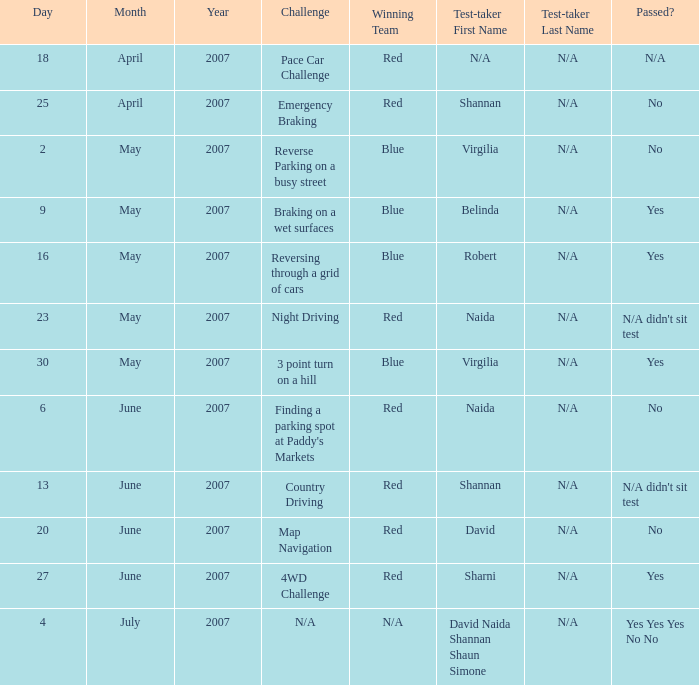On which air date was Robert the test-taker? 16 May 2007. 